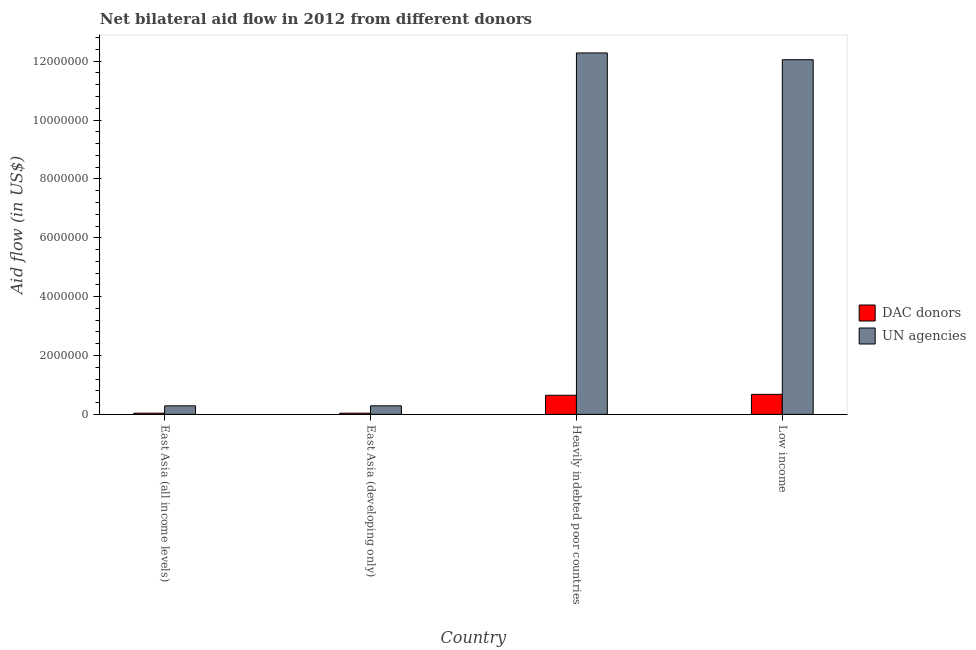Are the number of bars per tick equal to the number of legend labels?
Your response must be concise. Yes. Are the number of bars on each tick of the X-axis equal?
Provide a short and direct response. Yes. How many bars are there on the 1st tick from the left?
Your answer should be compact. 2. How many bars are there on the 4th tick from the right?
Your response must be concise. 2. What is the label of the 1st group of bars from the left?
Make the answer very short. East Asia (all income levels). In how many cases, is the number of bars for a given country not equal to the number of legend labels?
Ensure brevity in your answer.  0. What is the aid flow from un agencies in East Asia (developing only)?
Keep it short and to the point. 2.90e+05. Across all countries, what is the maximum aid flow from un agencies?
Keep it short and to the point. 1.23e+07. Across all countries, what is the minimum aid flow from dac donors?
Provide a succinct answer. 4.00e+04. In which country was the aid flow from dac donors maximum?
Ensure brevity in your answer.  Low income. In which country was the aid flow from dac donors minimum?
Offer a very short reply. East Asia (all income levels). What is the total aid flow from un agencies in the graph?
Provide a succinct answer. 2.49e+07. What is the difference between the aid flow from dac donors in East Asia (all income levels) and that in Heavily indebted poor countries?
Make the answer very short. -6.10e+05. What is the difference between the aid flow from dac donors in East Asia (all income levels) and the aid flow from un agencies in Heavily indebted poor countries?
Ensure brevity in your answer.  -1.22e+07. What is the average aid flow from dac donors per country?
Your response must be concise. 3.52e+05. What is the difference between the aid flow from dac donors and aid flow from un agencies in East Asia (developing only)?
Your answer should be very brief. -2.50e+05. What is the ratio of the aid flow from dac donors in East Asia (developing only) to that in Heavily indebted poor countries?
Offer a very short reply. 0.06. Is the aid flow from un agencies in East Asia (all income levels) less than that in Low income?
Offer a terse response. Yes. What is the difference between the highest and the second highest aid flow from dac donors?
Your answer should be very brief. 3.00e+04. What is the difference between the highest and the lowest aid flow from dac donors?
Provide a short and direct response. 6.40e+05. In how many countries, is the aid flow from un agencies greater than the average aid flow from un agencies taken over all countries?
Ensure brevity in your answer.  2. Is the sum of the aid flow from dac donors in East Asia (developing only) and Low income greater than the maximum aid flow from un agencies across all countries?
Give a very brief answer. No. What does the 1st bar from the left in Heavily indebted poor countries represents?
Your answer should be compact. DAC donors. What does the 1st bar from the right in East Asia (all income levels) represents?
Provide a succinct answer. UN agencies. How many bars are there?
Offer a terse response. 8. Are all the bars in the graph horizontal?
Ensure brevity in your answer.  No. What is the difference between two consecutive major ticks on the Y-axis?
Keep it short and to the point. 2.00e+06. Does the graph contain any zero values?
Your response must be concise. No. Does the graph contain grids?
Keep it short and to the point. No. Where does the legend appear in the graph?
Ensure brevity in your answer.  Center right. How are the legend labels stacked?
Offer a very short reply. Vertical. What is the title of the graph?
Offer a very short reply. Net bilateral aid flow in 2012 from different donors. Does "Domestic liabilities" appear as one of the legend labels in the graph?
Make the answer very short. No. What is the label or title of the Y-axis?
Ensure brevity in your answer.  Aid flow (in US$). What is the Aid flow (in US$) in DAC donors in East Asia (developing only)?
Offer a terse response. 4.00e+04. What is the Aid flow (in US$) of UN agencies in East Asia (developing only)?
Your answer should be compact. 2.90e+05. What is the Aid flow (in US$) of DAC donors in Heavily indebted poor countries?
Provide a short and direct response. 6.50e+05. What is the Aid flow (in US$) in UN agencies in Heavily indebted poor countries?
Your response must be concise. 1.23e+07. What is the Aid flow (in US$) of DAC donors in Low income?
Give a very brief answer. 6.80e+05. What is the Aid flow (in US$) in UN agencies in Low income?
Offer a terse response. 1.20e+07. Across all countries, what is the maximum Aid flow (in US$) of DAC donors?
Give a very brief answer. 6.80e+05. Across all countries, what is the maximum Aid flow (in US$) in UN agencies?
Keep it short and to the point. 1.23e+07. Across all countries, what is the minimum Aid flow (in US$) of DAC donors?
Your answer should be compact. 4.00e+04. Across all countries, what is the minimum Aid flow (in US$) in UN agencies?
Make the answer very short. 2.90e+05. What is the total Aid flow (in US$) of DAC donors in the graph?
Make the answer very short. 1.41e+06. What is the total Aid flow (in US$) in UN agencies in the graph?
Ensure brevity in your answer.  2.49e+07. What is the difference between the Aid flow (in US$) in UN agencies in East Asia (all income levels) and that in East Asia (developing only)?
Provide a succinct answer. 0. What is the difference between the Aid flow (in US$) of DAC donors in East Asia (all income levels) and that in Heavily indebted poor countries?
Provide a short and direct response. -6.10e+05. What is the difference between the Aid flow (in US$) of UN agencies in East Asia (all income levels) and that in Heavily indebted poor countries?
Keep it short and to the point. -1.20e+07. What is the difference between the Aid flow (in US$) in DAC donors in East Asia (all income levels) and that in Low income?
Your answer should be compact. -6.40e+05. What is the difference between the Aid flow (in US$) in UN agencies in East Asia (all income levels) and that in Low income?
Provide a succinct answer. -1.18e+07. What is the difference between the Aid flow (in US$) in DAC donors in East Asia (developing only) and that in Heavily indebted poor countries?
Ensure brevity in your answer.  -6.10e+05. What is the difference between the Aid flow (in US$) of UN agencies in East Asia (developing only) and that in Heavily indebted poor countries?
Provide a short and direct response. -1.20e+07. What is the difference between the Aid flow (in US$) in DAC donors in East Asia (developing only) and that in Low income?
Keep it short and to the point. -6.40e+05. What is the difference between the Aid flow (in US$) of UN agencies in East Asia (developing only) and that in Low income?
Your answer should be very brief. -1.18e+07. What is the difference between the Aid flow (in US$) in DAC donors in Heavily indebted poor countries and that in Low income?
Your answer should be compact. -3.00e+04. What is the difference between the Aid flow (in US$) in DAC donors in East Asia (all income levels) and the Aid flow (in US$) in UN agencies in East Asia (developing only)?
Give a very brief answer. -2.50e+05. What is the difference between the Aid flow (in US$) of DAC donors in East Asia (all income levels) and the Aid flow (in US$) of UN agencies in Heavily indebted poor countries?
Offer a very short reply. -1.22e+07. What is the difference between the Aid flow (in US$) in DAC donors in East Asia (all income levels) and the Aid flow (in US$) in UN agencies in Low income?
Offer a terse response. -1.20e+07. What is the difference between the Aid flow (in US$) in DAC donors in East Asia (developing only) and the Aid flow (in US$) in UN agencies in Heavily indebted poor countries?
Offer a very short reply. -1.22e+07. What is the difference between the Aid flow (in US$) of DAC donors in East Asia (developing only) and the Aid flow (in US$) of UN agencies in Low income?
Provide a succinct answer. -1.20e+07. What is the difference between the Aid flow (in US$) in DAC donors in Heavily indebted poor countries and the Aid flow (in US$) in UN agencies in Low income?
Make the answer very short. -1.14e+07. What is the average Aid flow (in US$) of DAC donors per country?
Give a very brief answer. 3.52e+05. What is the average Aid flow (in US$) of UN agencies per country?
Your answer should be compact. 6.23e+06. What is the difference between the Aid flow (in US$) of DAC donors and Aid flow (in US$) of UN agencies in East Asia (all income levels)?
Provide a short and direct response. -2.50e+05. What is the difference between the Aid flow (in US$) in DAC donors and Aid flow (in US$) in UN agencies in East Asia (developing only)?
Ensure brevity in your answer.  -2.50e+05. What is the difference between the Aid flow (in US$) in DAC donors and Aid flow (in US$) in UN agencies in Heavily indebted poor countries?
Your answer should be compact. -1.16e+07. What is the difference between the Aid flow (in US$) of DAC donors and Aid flow (in US$) of UN agencies in Low income?
Your answer should be very brief. -1.14e+07. What is the ratio of the Aid flow (in US$) of DAC donors in East Asia (all income levels) to that in East Asia (developing only)?
Give a very brief answer. 1. What is the ratio of the Aid flow (in US$) in UN agencies in East Asia (all income levels) to that in East Asia (developing only)?
Your answer should be compact. 1. What is the ratio of the Aid flow (in US$) of DAC donors in East Asia (all income levels) to that in Heavily indebted poor countries?
Your answer should be compact. 0.06. What is the ratio of the Aid flow (in US$) of UN agencies in East Asia (all income levels) to that in Heavily indebted poor countries?
Give a very brief answer. 0.02. What is the ratio of the Aid flow (in US$) in DAC donors in East Asia (all income levels) to that in Low income?
Offer a very short reply. 0.06. What is the ratio of the Aid flow (in US$) in UN agencies in East Asia (all income levels) to that in Low income?
Provide a succinct answer. 0.02. What is the ratio of the Aid flow (in US$) of DAC donors in East Asia (developing only) to that in Heavily indebted poor countries?
Your answer should be very brief. 0.06. What is the ratio of the Aid flow (in US$) of UN agencies in East Asia (developing only) to that in Heavily indebted poor countries?
Your answer should be very brief. 0.02. What is the ratio of the Aid flow (in US$) in DAC donors in East Asia (developing only) to that in Low income?
Offer a terse response. 0.06. What is the ratio of the Aid flow (in US$) of UN agencies in East Asia (developing only) to that in Low income?
Provide a succinct answer. 0.02. What is the ratio of the Aid flow (in US$) in DAC donors in Heavily indebted poor countries to that in Low income?
Offer a terse response. 0.96. What is the ratio of the Aid flow (in US$) of UN agencies in Heavily indebted poor countries to that in Low income?
Make the answer very short. 1.02. What is the difference between the highest and the lowest Aid flow (in US$) in DAC donors?
Provide a succinct answer. 6.40e+05. What is the difference between the highest and the lowest Aid flow (in US$) in UN agencies?
Offer a terse response. 1.20e+07. 